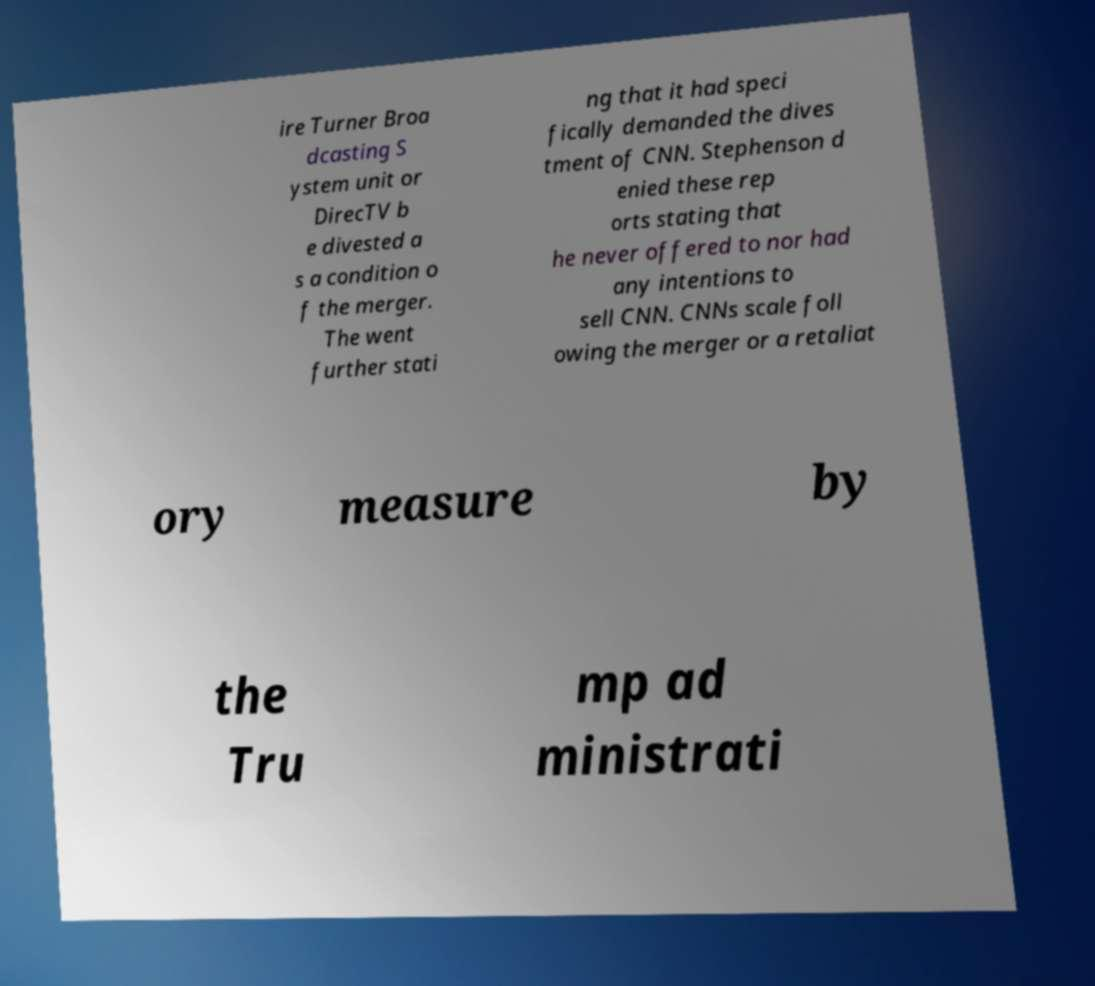Please read and relay the text visible in this image. What does it say? ire Turner Broa dcasting S ystem unit or DirecTV b e divested a s a condition o f the merger. The went further stati ng that it had speci fically demanded the dives tment of CNN. Stephenson d enied these rep orts stating that he never offered to nor had any intentions to sell CNN. CNNs scale foll owing the merger or a retaliat ory measure by the Tru mp ad ministrati 